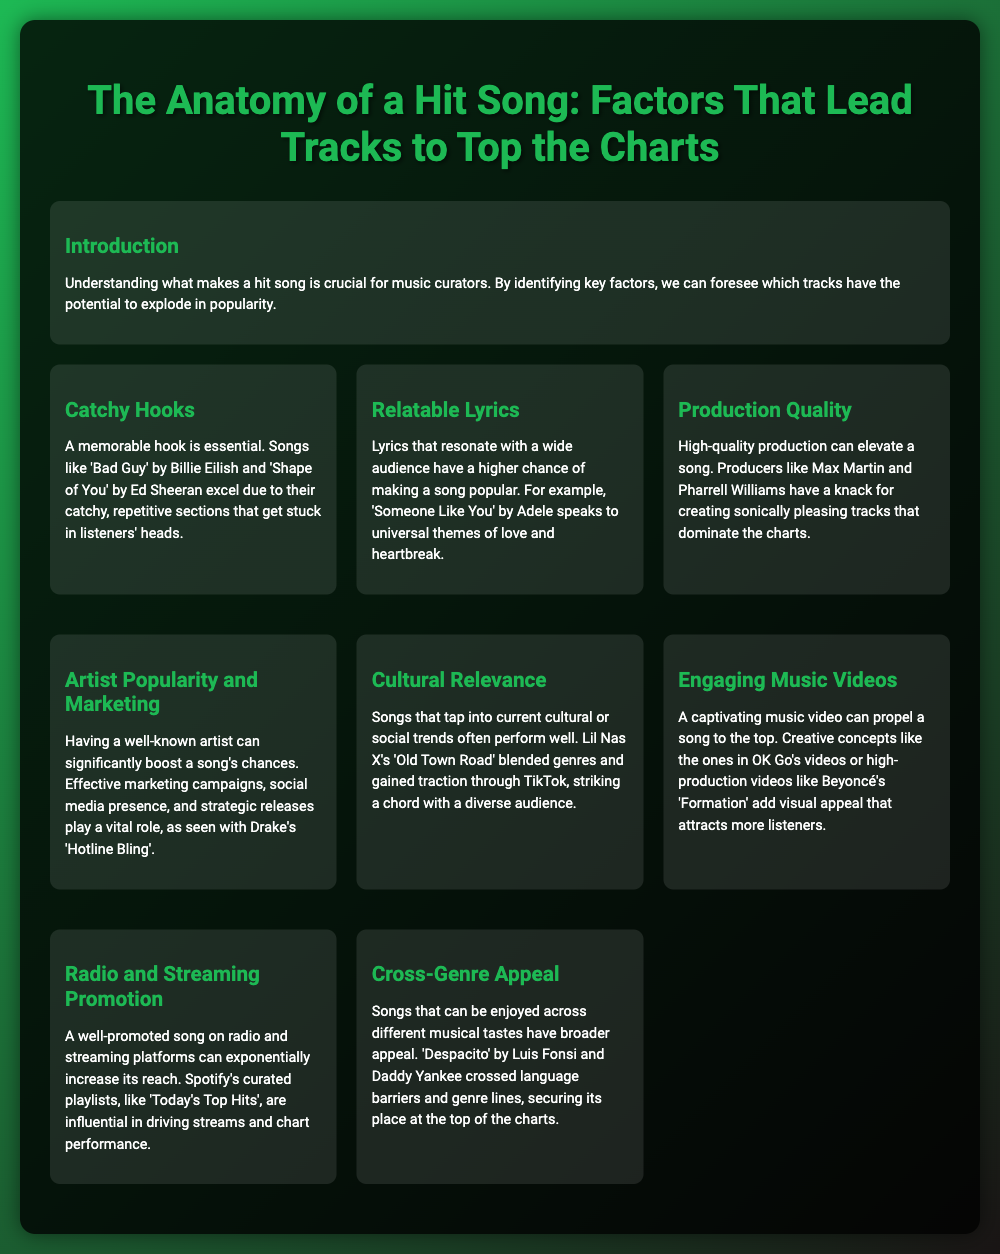What is the main title of the poster? The main title is indicated at the top of the poster, which describes the overall topic.
Answer: The Anatomy of a Hit Song: Factors That Lead Tracks to Top the Charts Who are two songwriters mentioned as influential producers? The document lists key producers that have a significant impact on song quality and chart performance.
Answer: Max Martin and Pharrell Williams Which song's lyrics relate to universal themes of love and heartbreak? The poster provides an example of a track that resonates emotionally with a wide audience through its lyrics.
Answer: Someone Like You What is one factor that can significantly boost a song's chances besides its quality? The document discusses various elements that affect a song's success, including artist reputation and marketing.
Answer: Artist Popularity Which song gained traction through TikTok as a cultural reference? This song is provided as an example of how cultural trends can affect popularity and chart performance.
Answer: Old Town Road What type of appeal allows a song to reach diverse audiences? The poster mentions a quality that expands a song's target demographic through musical versatility.
Answer: Cross-Genre Appeal Name a playlist that influences song streams and chart performance. The document highlights a specific curated playlist known for promoting popular songs through streaming platforms.
Answer: Today's Top Hits What is essential for creating a memorable impact in a song? The poster emphasizes a certain catchy element as critical to a song's recognition and retention in listeners' minds.
Answer: Catchy Hooks 